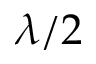<formula> <loc_0><loc_0><loc_500><loc_500>\lambda / 2</formula> 